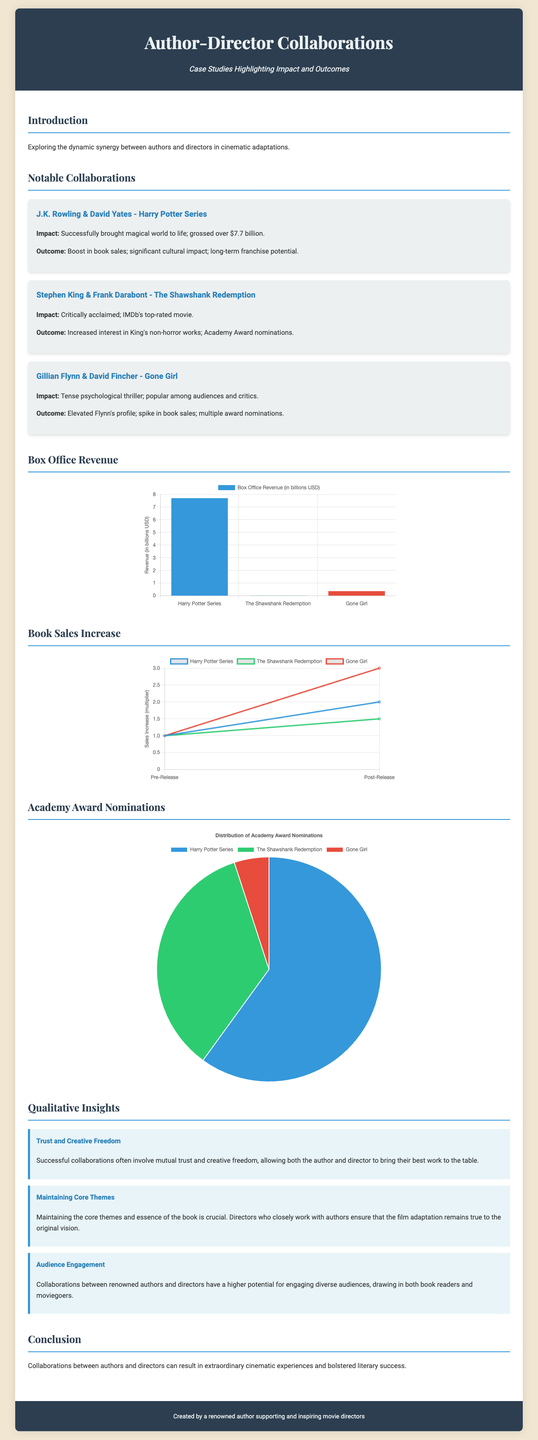What is the total box office revenue for the Harry Potter series? The box office revenue for the Harry Potter series is over $7.7 billion as stated in the collaboration card.
Answer: $7.7 billion How many Academy Award nominations did The Shawshank Redemption receive? The document lists that The Shawshank Redemption received 7 Academy Award nominations in the pie chart section.
Answer: 7 What genre is Gone Girl classified as? The collaboration card states that Gone Girl is a tense psychological thriller.
Answer: Psychological thriller What was the spike in book sales for Gone Girl after the movie release? The line chart shows a sales increase multiplier from 1 to 3 for Gone Girl, indicating the change post-release.
Answer: 3 Which collaboration had a significant cultural impact according to the document? The document mentions that the collaboration between J.K. Rowling and David Yates for the Harry Potter series had significant cultural impact.
Answer: J.K. Rowling & David Yates What is a key factor for successful collaborations between authors and directors? The document highlights that mutual trust and creative freedom are important for successful collaborations, as noted in the qualitative insights section.
Answer: Trust and creative freedom What color represents the Harry Potter series in the box office revenue chart? The box office chart shows the color blue used to represent the Harry Potter series.
Answer: Blue Which adaptation led to increased interest in Stephen King's non-horror works? The collaboration between Stephen King and Frank Darabont on The Shawshank Redemption led to increased interest, as stated in the collaboration card.
Answer: The Shawshank Redemption 